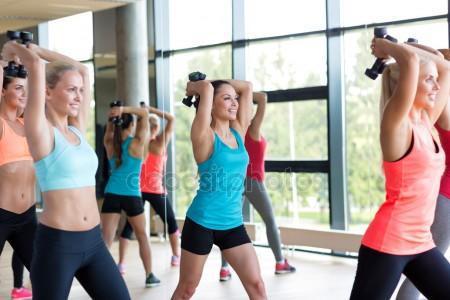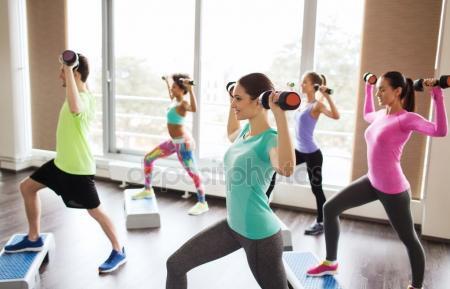The first image is the image on the left, the second image is the image on the right. Evaluate the accuracy of this statement regarding the images: "Nine or fewer humans are visible.". Is it true? Answer yes or no. No. The first image is the image on the left, the second image is the image on the right. For the images shown, is this caption "There are nine people working out." true? Answer yes or no. Yes. 